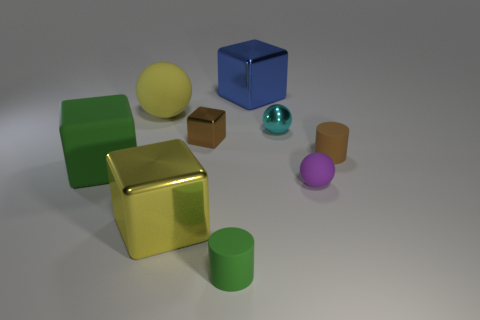Add 1 tiny matte cylinders. How many objects exist? 10 Subtract all gray spheres. Subtract all red blocks. How many spheres are left? 3 Subtract all blocks. How many objects are left? 5 Subtract all blue metal blocks. Subtract all small brown shiny cubes. How many objects are left? 7 Add 4 large balls. How many large balls are left? 5 Add 2 tiny yellow matte spheres. How many tiny yellow matte spheres exist? 2 Subtract 0 gray balls. How many objects are left? 9 